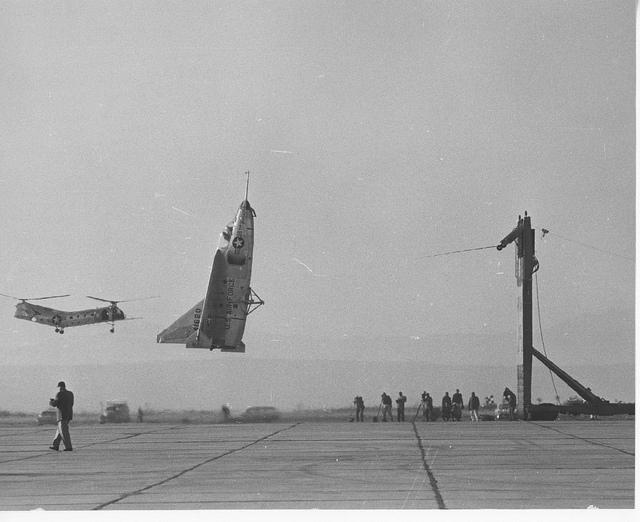How many vehicles are shown?
Quick response, please. 2. How many propellers does the helicopter have?
Write a very short answer. 2. What are the people looking at?
Concise answer only. Rocket. Is the plane falling?
Write a very short answer. No. 